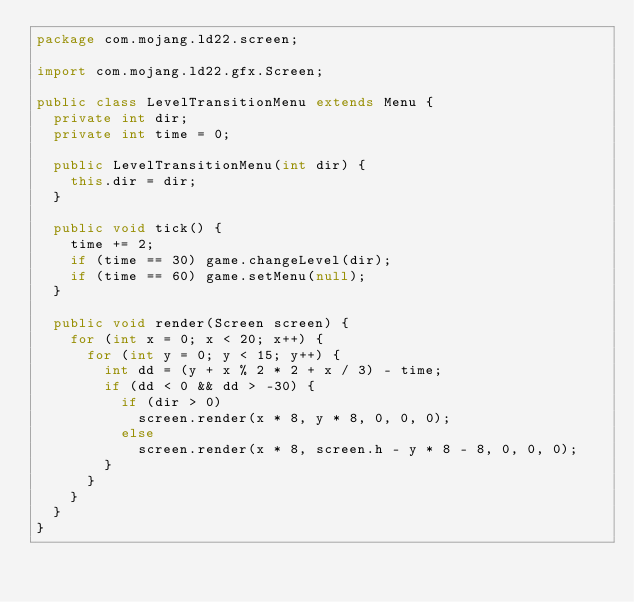Convert code to text. <code><loc_0><loc_0><loc_500><loc_500><_Java_>package com.mojang.ld22.screen;

import com.mojang.ld22.gfx.Screen;

public class LevelTransitionMenu extends Menu {
	private int dir;
	private int time = 0;

	public LevelTransitionMenu(int dir) {
		this.dir = dir;
	}

	public void tick() {
		time += 2;
		if (time == 30) game.changeLevel(dir);
		if (time == 60) game.setMenu(null);
	}

	public void render(Screen screen) {
		for (int x = 0; x < 20; x++) {
			for (int y = 0; y < 15; y++) {
				int dd = (y + x % 2 * 2 + x / 3) - time;
				if (dd < 0 && dd > -30) {
					if (dir > 0)
						screen.render(x * 8, y * 8, 0, 0, 0);
					else
						screen.render(x * 8, screen.h - y * 8 - 8, 0, 0, 0);
				}
			}
		}
	}
}
</code> 